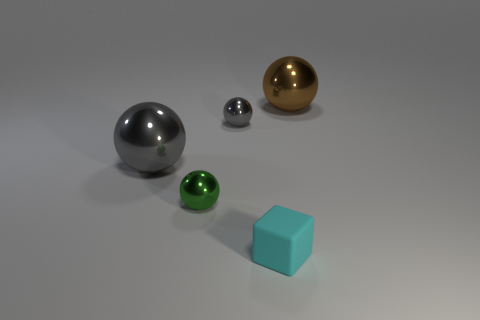Is there a big brown thing that has the same material as the big gray object?
Ensure brevity in your answer.  Yes. What is the color of the tiny thing behind the green sphere to the right of the large metallic object that is in front of the brown metal ball?
Your response must be concise. Gray. Is the material of the big ball on the right side of the small gray sphere the same as the large object on the left side of the big brown thing?
Provide a short and direct response. Yes. The gray shiny object that is in front of the small gray metallic object has what shape?
Make the answer very short. Sphere. How many things are green metallic balls or tiny things left of the small gray metal thing?
Ensure brevity in your answer.  1. Does the green ball have the same material as the tiny gray sphere?
Make the answer very short. Yes. Are there an equal number of rubber blocks to the left of the cube and brown metallic balls to the left of the small gray metallic object?
Provide a short and direct response. Yes. How many green objects are to the right of the cyan object?
Give a very brief answer. 0. What number of objects are either small green metallic objects or tiny yellow metallic balls?
Ensure brevity in your answer.  1. What number of gray shiny spheres have the same size as the green object?
Give a very brief answer. 1. 